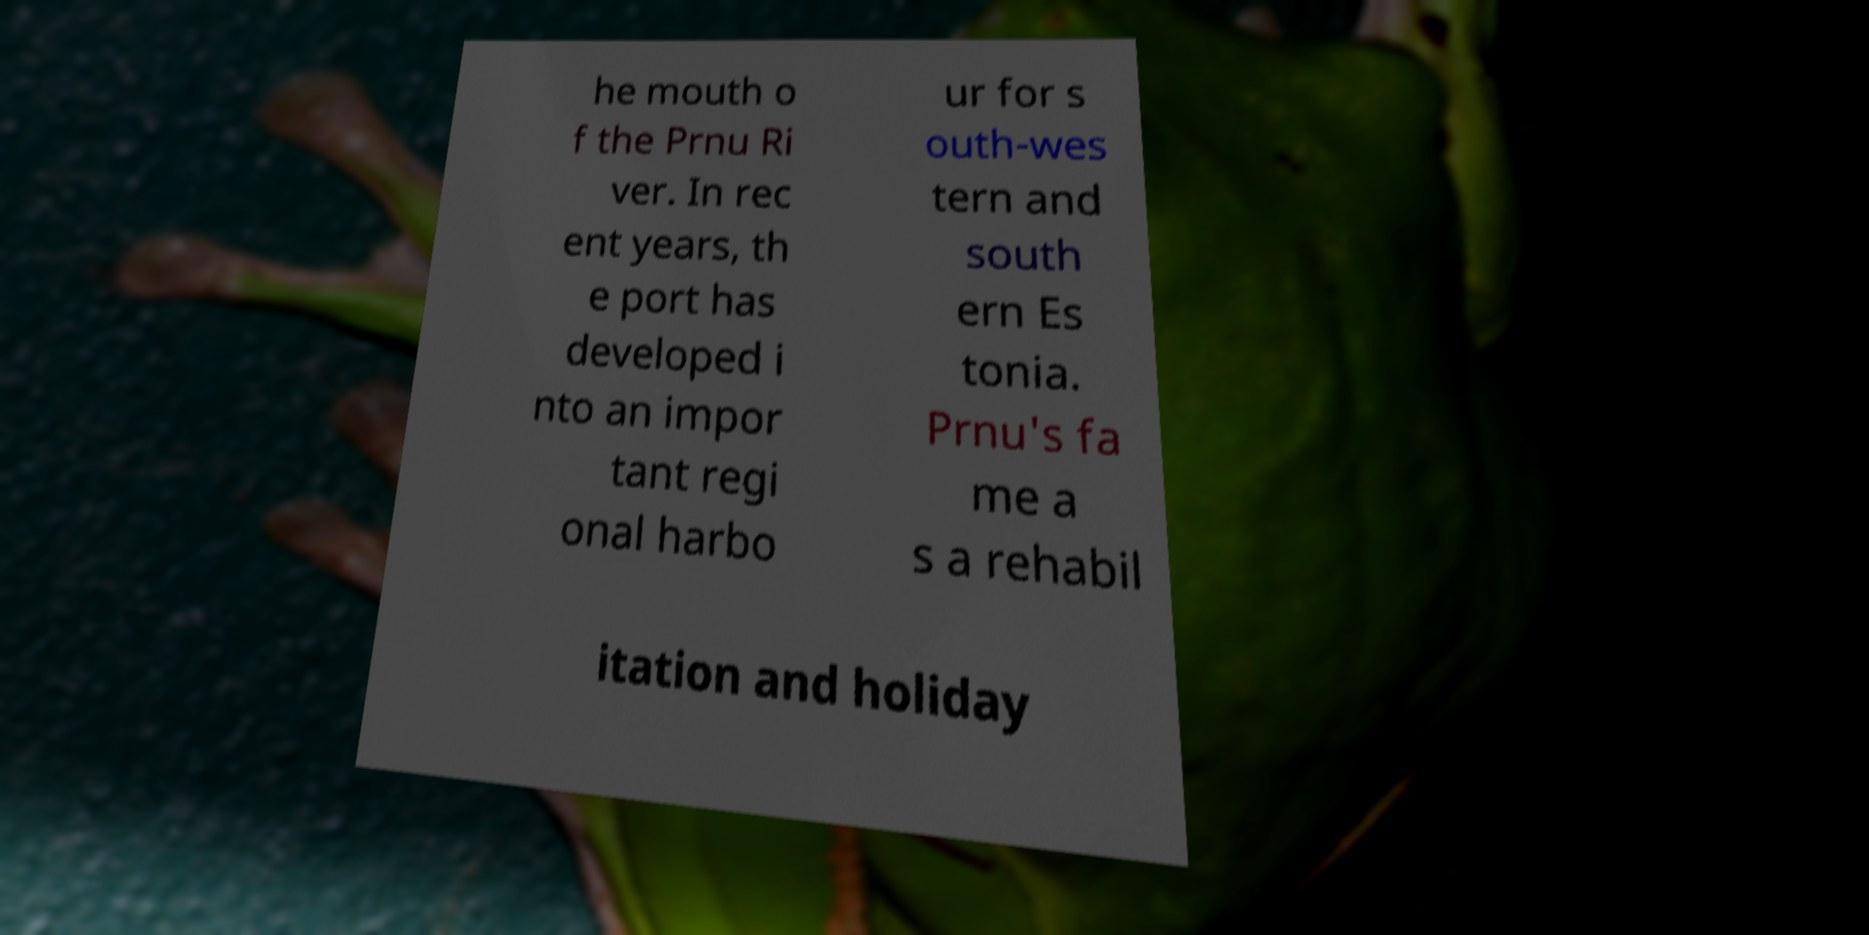There's text embedded in this image that I need extracted. Can you transcribe it verbatim? he mouth o f the Prnu Ri ver. In rec ent years, th e port has developed i nto an impor tant regi onal harbo ur for s outh-wes tern and south ern Es tonia. Prnu's fa me a s a rehabil itation and holiday 